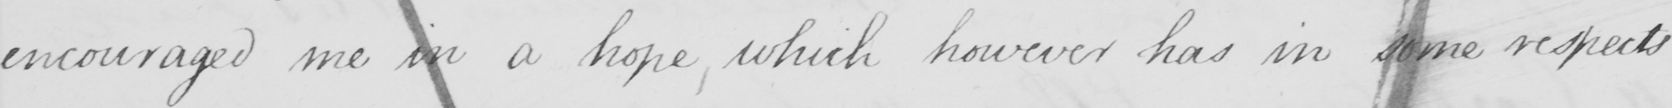Please transcribe the handwritten text in this image. encouraged me in a hope, which however has in some respects 